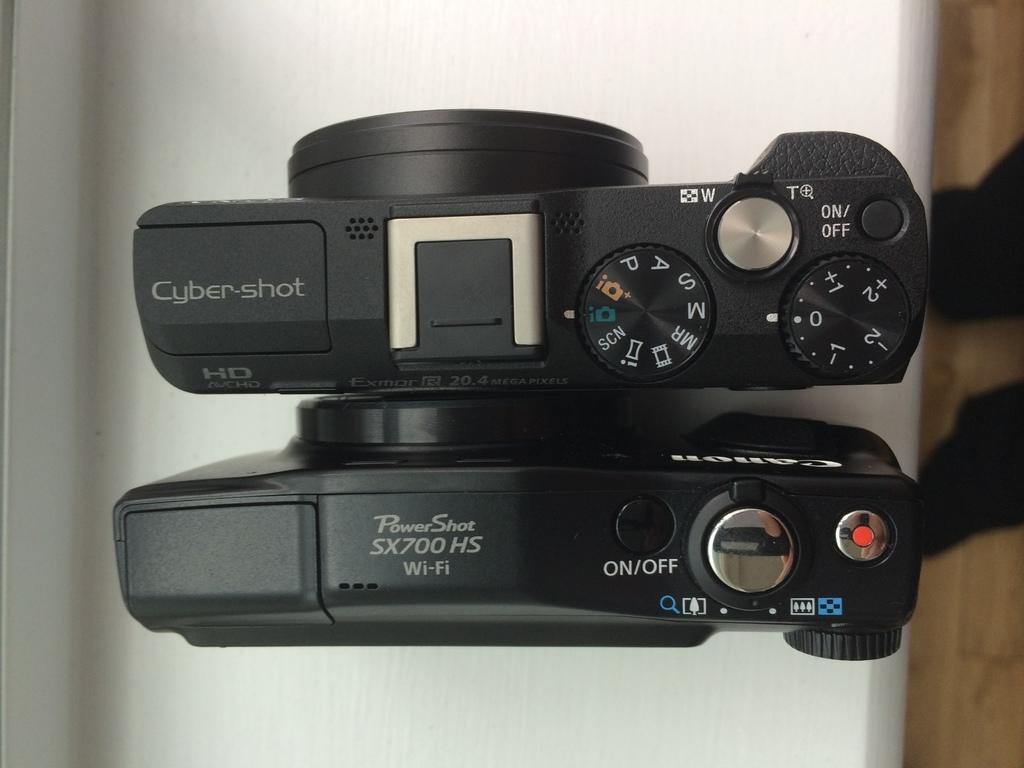<image>
Render a clear and concise summary of the photo. a over head view of two cameras reading Cybershot and PowerShot 